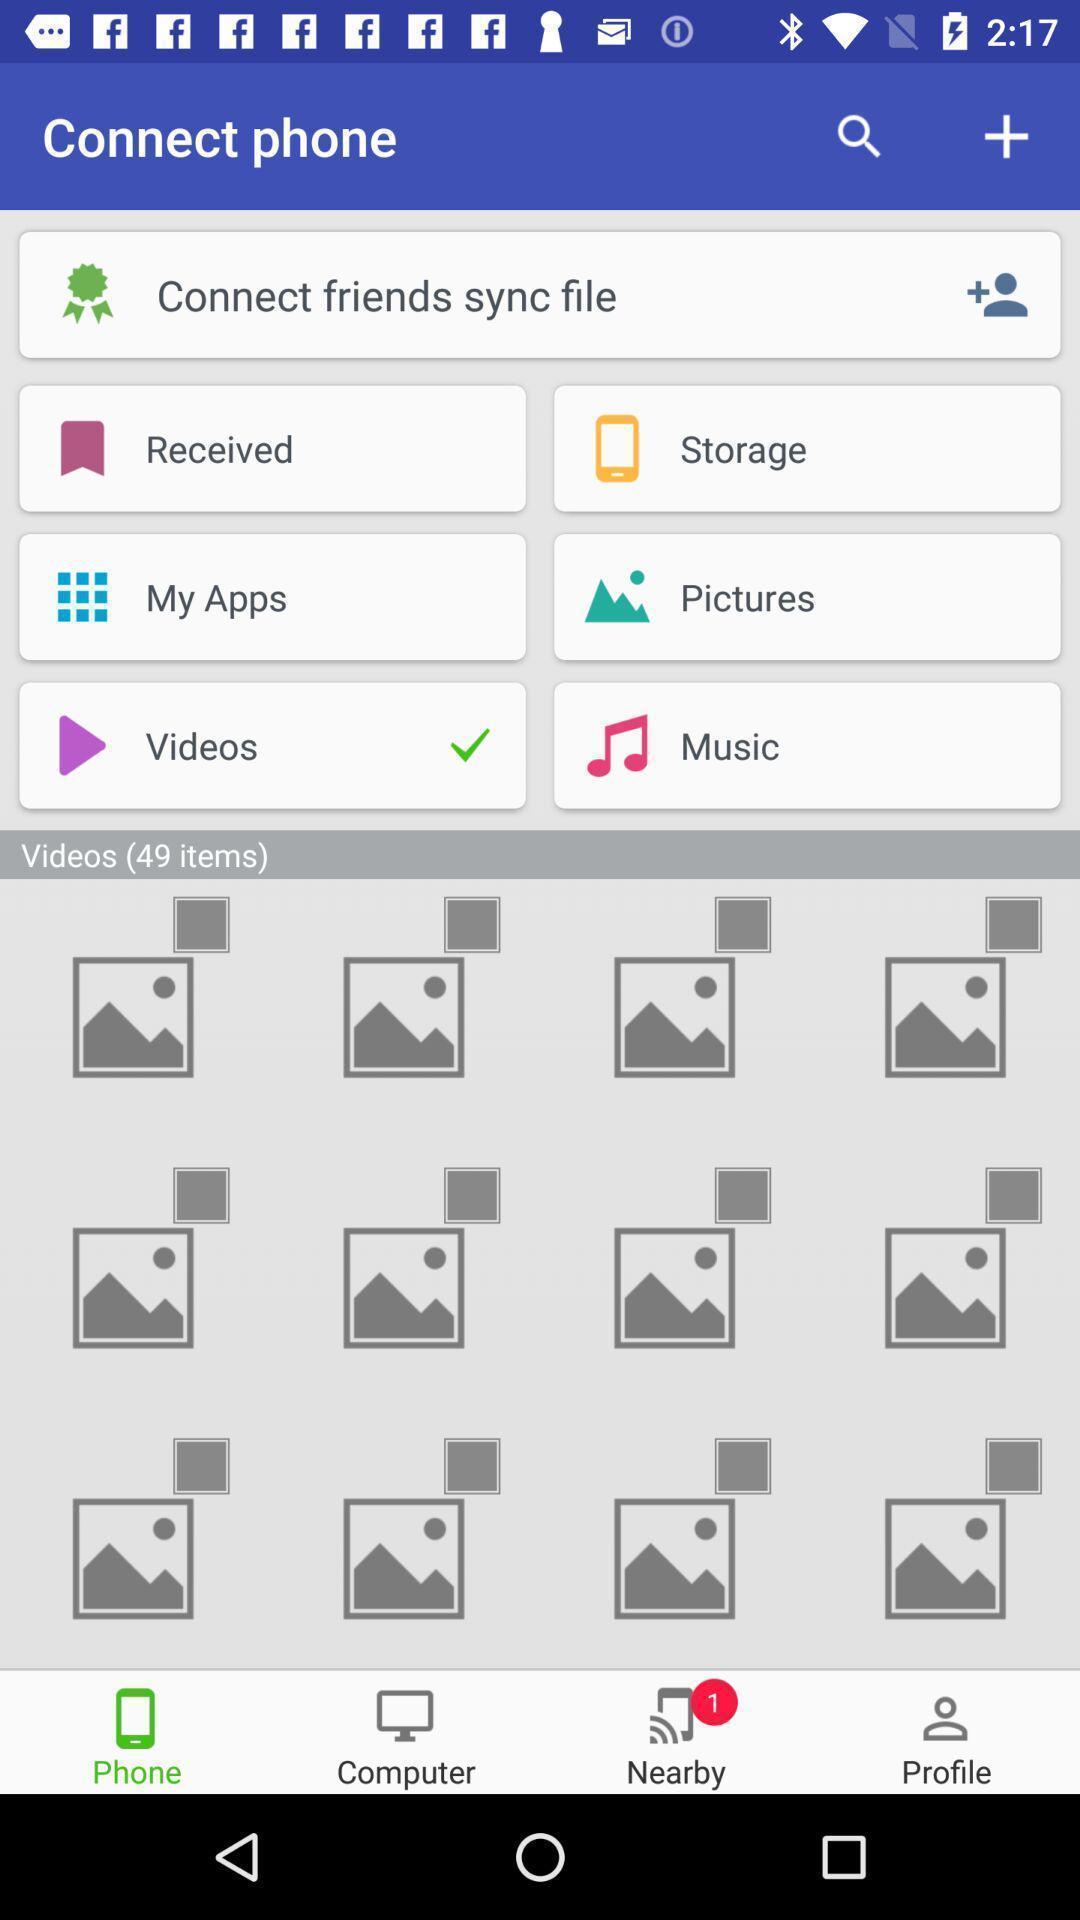Describe this image in words. Screen showing connect phone with videos option selected. 